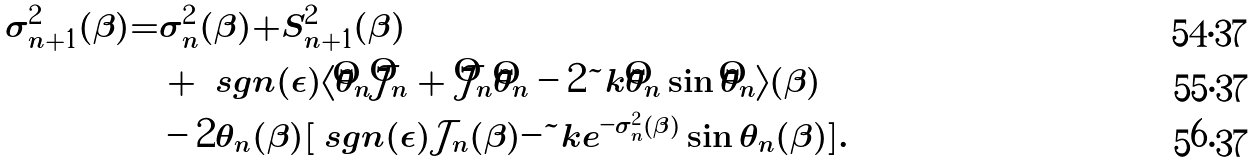Convert formula to latex. <formula><loc_0><loc_0><loc_500><loc_500>\sigma _ { n + 1 } ^ { 2 } ( \beta ) = & \sigma _ { n } ^ { 2 } ( \beta ) + S _ { n + 1 } ^ { 2 } ( \beta ) \\ & + \ s g n ( \epsilon ) \langle \hat { \theta } _ { n } \hat { \mathcal { J } } _ { n } + \hat { \mathcal { J } } _ { n } \hat { \theta } _ { n } - 2 \tilde { k } \hat { \theta } _ { n } \sin \hat { \theta } _ { n } \rangle ( \beta ) \\ & - 2 \theta _ { n } ( \beta ) [ \ s g n ( \epsilon ) \mathcal { J } _ { n } ( \beta ) - \tilde { k } e ^ { - \sigma _ { n } ^ { 2 } ( \beta ) } \sin \theta _ { n } ( \beta ) ] .</formula> 